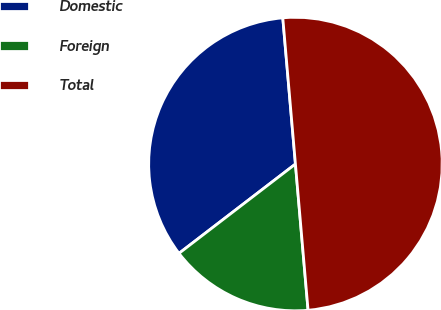Convert chart. <chart><loc_0><loc_0><loc_500><loc_500><pie_chart><fcel>Domestic<fcel>Foreign<fcel>Total<nl><fcel>34.04%<fcel>15.96%<fcel>50.0%<nl></chart> 